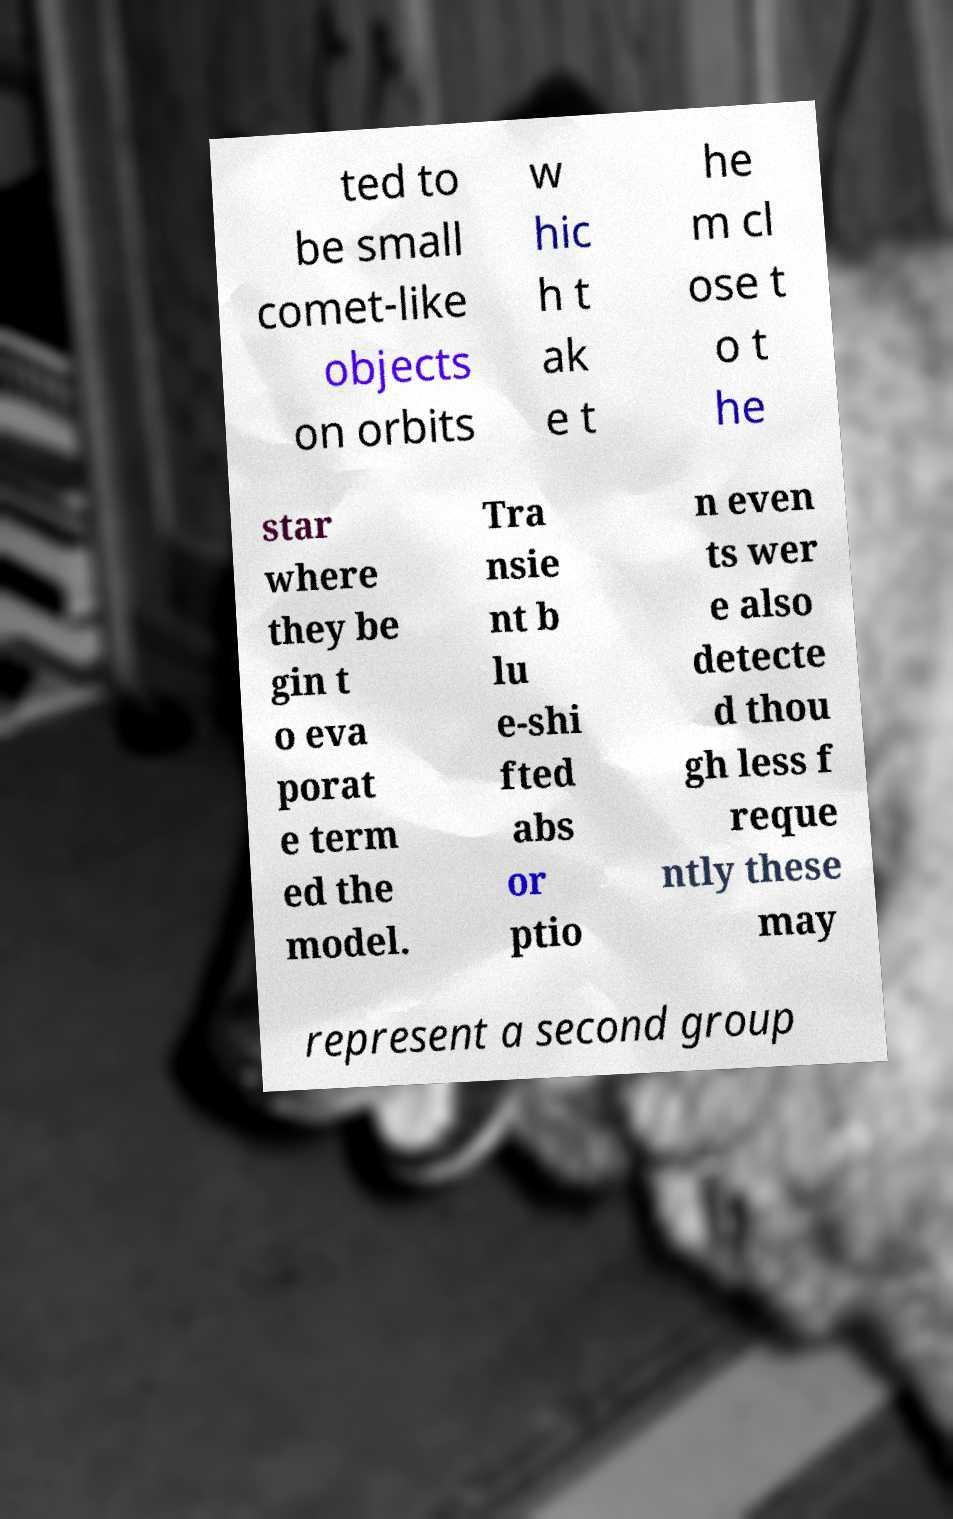What messages or text are displayed in this image? I need them in a readable, typed format. ted to be small comet-like objects on orbits w hic h t ak e t he m cl ose t o t he star where they be gin t o eva porat e term ed the model. Tra nsie nt b lu e-shi fted abs or ptio n even ts wer e also detecte d thou gh less f reque ntly these may represent a second group 